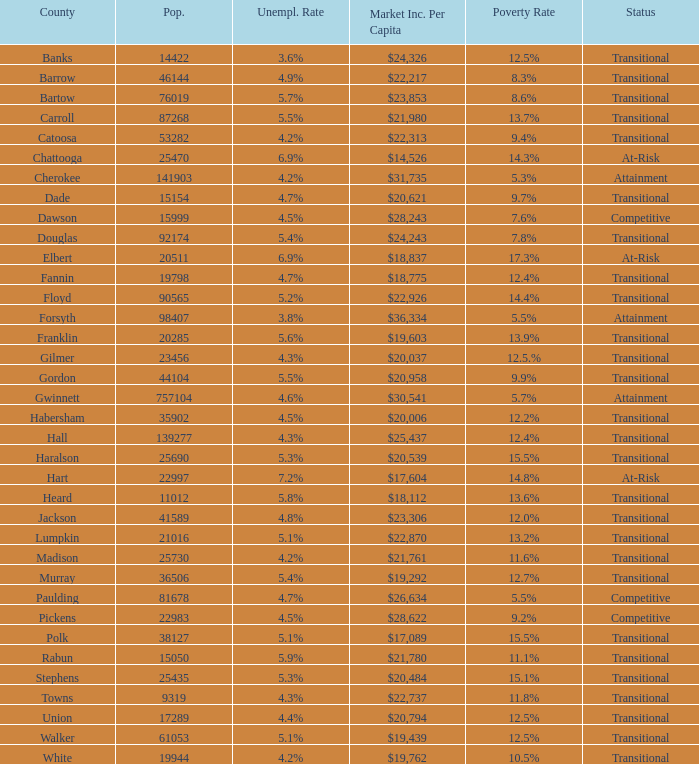How many status' are there with a population of 90565? 1.0. Would you be able to parse every entry in this table? {'header': ['County', 'Pop.', 'Unempl. Rate', 'Market Inc. Per Capita', 'Poverty Rate', 'Status'], 'rows': [['Banks', '14422', '3.6%', '$24,326', '12.5%', 'Transitional'], ['Barrow', '46144', '4.9%', '$22,217', '8.3%', 'Transitional'], ['Bartow', '76019', '5.7%', '$23,853', '8.6%', 'Transitional'], ['Carroll', '87268', '5.5%', '$21,980', '13.7%', 'Transitional'], ['Catoosa', '53282', '4.2%', '$22,313', '9.4%', 'Transitional'], ['Chattooga', '25470', '6.9%', '$14,526', '14.3%', 'At-Risk'], ['Cherokee', '141903', '4.2%', '$31,735', '5.3%', 'Attainment'], ['Dade', '15154', '4.7%', '$20,621', '9.7%', 'Transitional'], ['Dawson', '15999', '4.5%', '$28,243', '7.6%', 'Competitive'], ['Douglas', '92174', '5.4%', '$24,243', '7.8%', 'Transitional'], ['Elbert', '20511', '6.9%', '$18,837', '17.3%', 'At-Risk'], ['Fannin', '19798', '4.7%', '$18,775', '12.4%', 'Transitional'], ['Floyd', '90565', '5.2%', '$22,926', '14.4%', 'Transitional'], ['Forsyth', '98407', '3.8%', '$36,334', '5.5%', 'Attainment'], ['Franklin', '20285', '5.6%', '$19,603', '13.9%', 'Transitional'], ['Gilmer', '23456', '4.3%', '$20,037', '12.5.%', 'Transitional'], ['Gordon', '44104', '5.5%', '$20,958', '9.9%', 'Transitional'], ['Gwinnett', '757104', '4.6%', '$30,541', '5.7%', 'Attainment'], ['Habersham', '35902', '4.5%', '$20,006', '12.2%', 'Transitional'], ['Hall', '139277', '4.3%', '$25,437', '12.4%', 'Transitional'], ['Haralson', '25690', '5.3%', '$20,539', '15.5%', 'Transitional'], ['Hart', '22997', '7.2%', '$17,604', '14.8%', 'At-Risk'], ['Heard', '11012', '5.8%', '$18,112', '13.6%', 'Transitional'], ['Jackson', '41589', '4.8%', '$23,306', '12.0%', 'Transitional'], ['Lumpkin', '21016', '5.1%', '$22,870', '13.2%', 'Transitional'], ['Madison', '25730', '4.2%', '$21,761', '11.6%', 'Transitional'], ['Murray', '36506', '5.4%', '$19,292', '12.7%', 'Transitional'], ['Paulding', '81678', '4.7%', '$26,634', '5.5%', 'Competitive'], ['Pickens', '22983', '4.5%', '$28,622', '9.2%', 'Competitive'], ['Polk', '38127', '5.1%', '$17,089', '15.5%', 'Transitional'], ['Rabun', '15050', '5.9%', '$21,780', '11.1%', 'Transitional'], ['Stephens', '25435', '5.3%', '$20,484', '15.1%', 'Transitional'], ['Towns', '9319', '4.3%', '$22,737', '11.8%', 'Transitional'], ['Union', '17289', '4.4%', '$20,794', '12.5%', 'Transitional'], ['Walker', '61053', '5.1%', '$19,439', '12.5%', 'Transitional'], ['White', '19944', '4.2%', '$19,762', '10.5%', 'Transitional']]} 